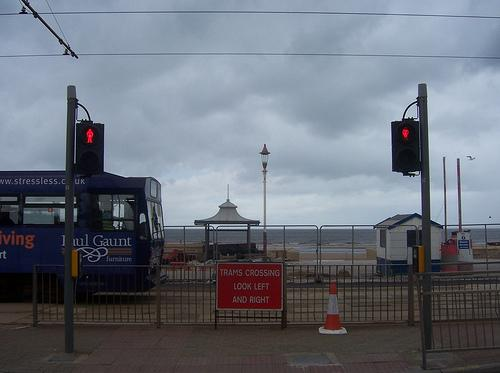Seeing dark clouds in the sky will remind you to bring what accessory that would be helpful if it starts to rain?

Choices:
A) necklace
B) eyeglasses
C) umbrella
D) watch umbrella 